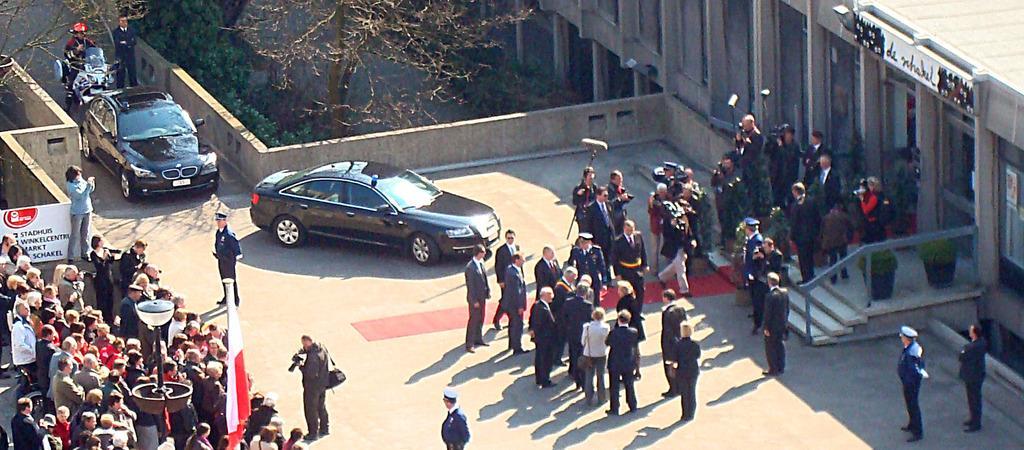Can you describe this image briefly? In this image we can see there are a few people standing, we can also see there are two cars and a bike approaching, in the background of the image there are lamp posts, trees, stairs and a building. 